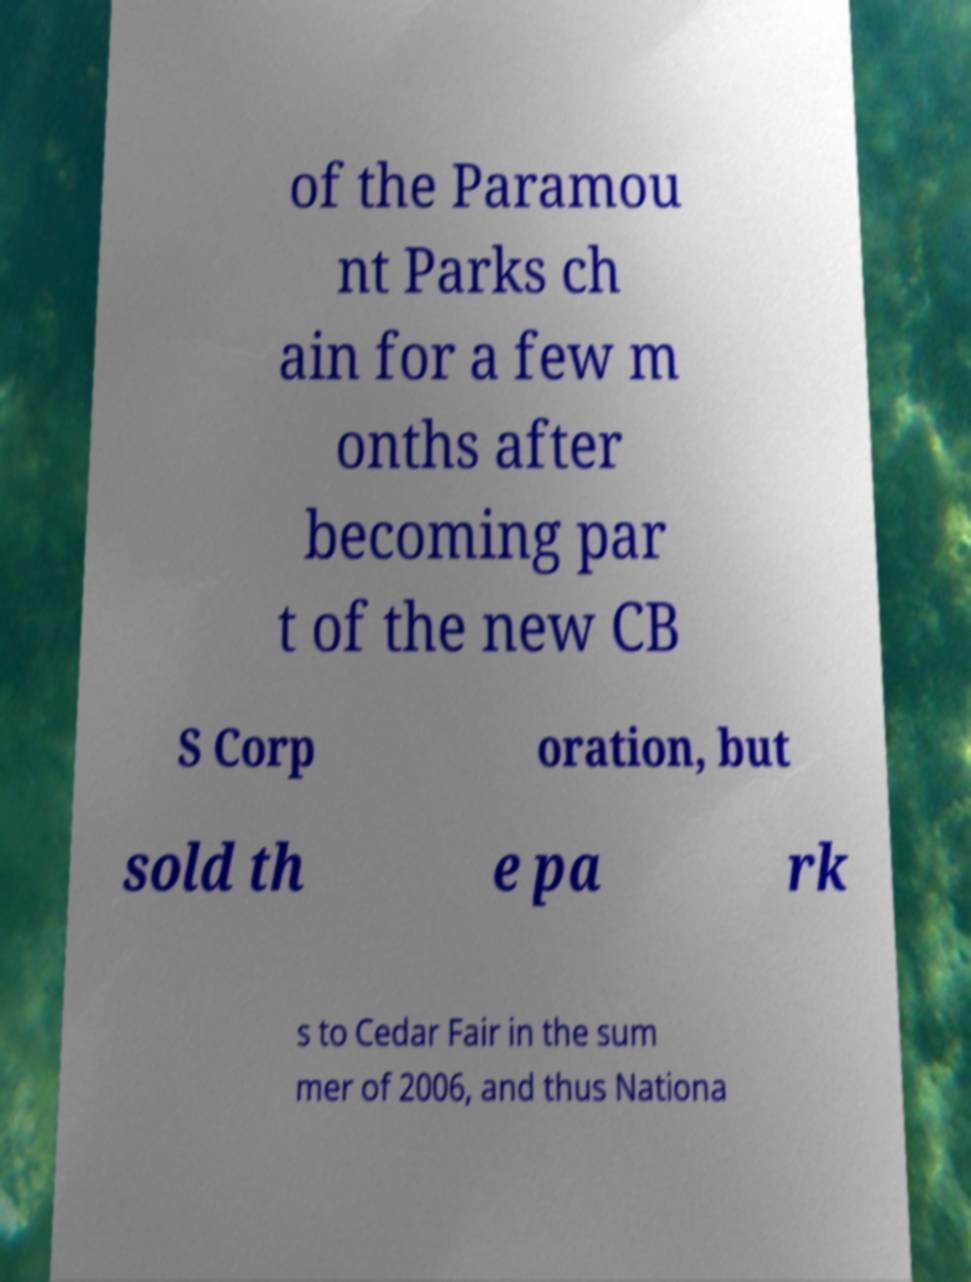Please read and relay the text visible in this image. What does it say? of the Paramou nt Parks ch ain for a few m onths after becoming par t of the new CB S Corp oration, but sold th e pa rk s to Cedar Fair in the sum mer of 2006, and thus Nationa 